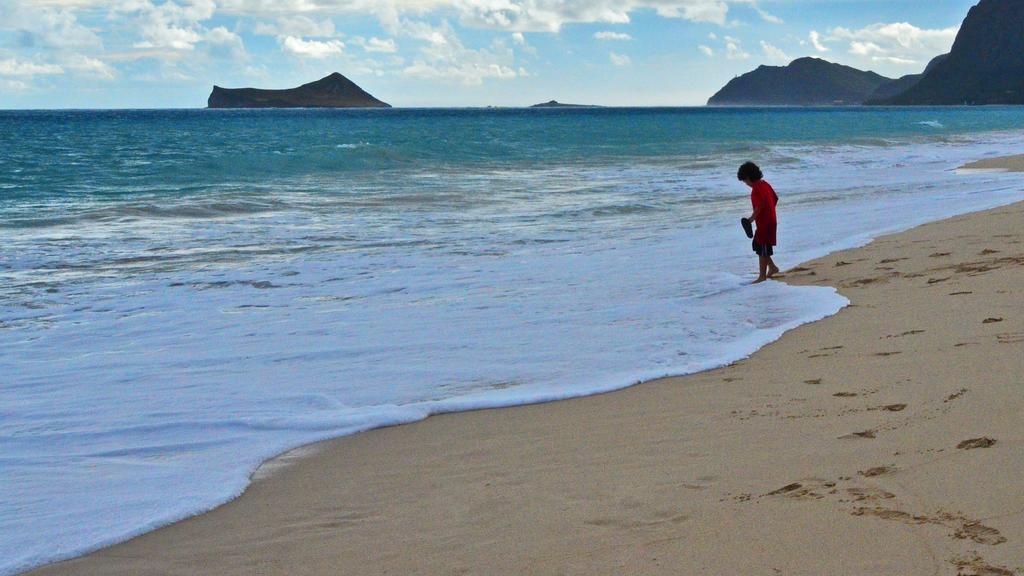Describe this image in one or two sentences. In this picture we can see a boy holding an object with his hand, standing on sand, water, rocks and in the background we can see the sky with clouds. 